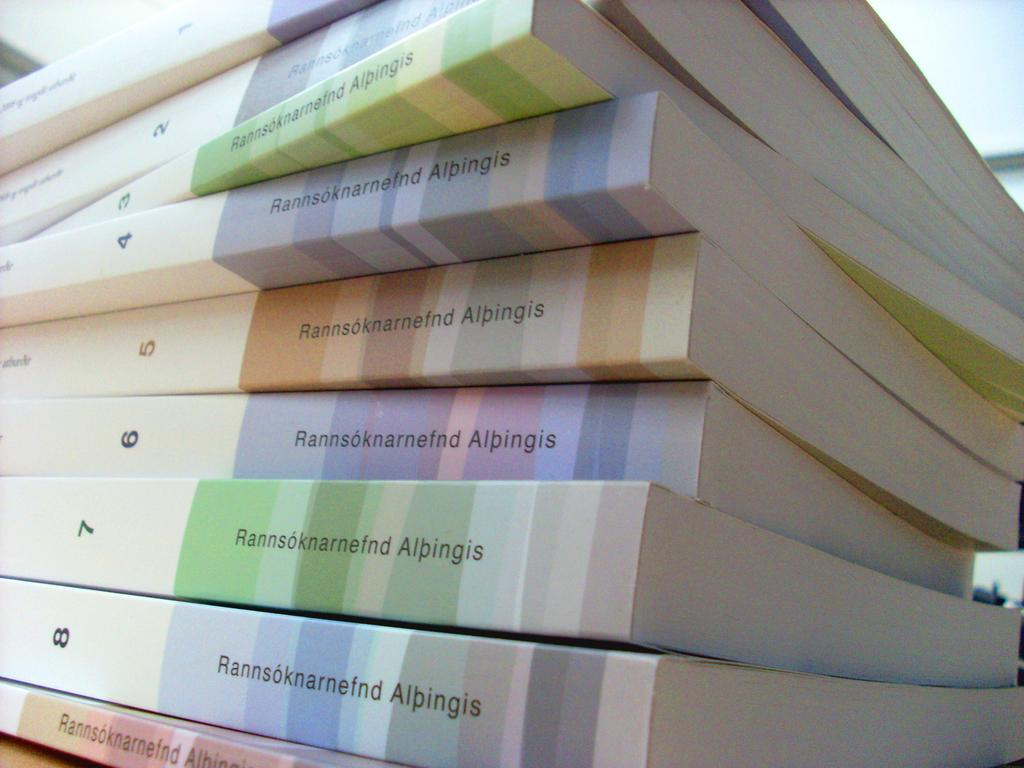<image>
Share a concise interpretation of the image provided. A stack of paperback books numbered from 1 to 8 that say Rannsoknarnefnd Alpingis. 